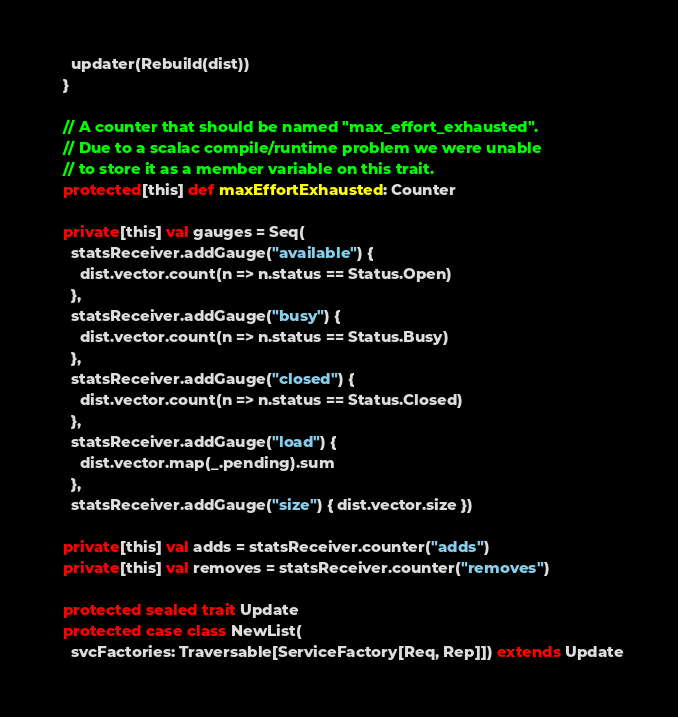<code> <loc_0><loc_0><loc_500><loc_500><_Scala_>    updater(Rebuild(dist))
  }

  // A counter that should be named "max_effort_exhausted".
  // Due to a scalac compile/runtime problem we were unable
  // to store it as a member variable on this trait.
  protected[this] def maxEffortExhausted: Counter

  private[this] val gauges = Seq(
    statsReceiver.addGauge("available") {
      dist.vector.count(n => n.status == Status.Open)
    },
    statsReceiver.addGauge("busy") {
      dist.vector.count(n => n.status == Status.Busy)
    },
    statsReceiver.addGauge("closed") {
      dist.vector.count(n => n.status == Status.Closed)
    },
    statsReceiver.addGauge("load") {
      dist.vector.map(_.pending).sum
    },
    statsReceiver.addGauge("size") { dist.vector.size })

  private[this] val adds = statsReceiver.counter("adds")
  private[this] val removes = statsReceiver.counter("removes")

  protected sealed trait Update
  protected case class NewList(
    svcFactories: Traversable[ServiceFactory[Req, Rep]]) extends Update</code> 